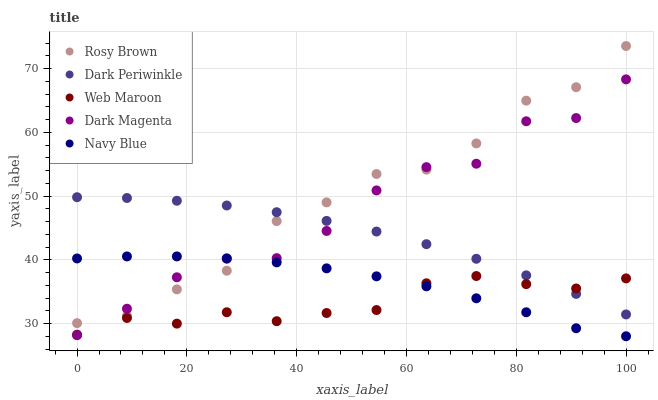Does Web Maroon have the minimum area under the curve?
Answer yes or no. Yes. Does Rosy Brown have the maximum area under the curve?
Answer yes or no. Yes. Does Rosy Brown have the minimum area under the curve?
Answer yes or no. No. Does Web Maroon have the maximum area under the curve?
Answer yes or no. No. Is Dark Periwinkle the smoothest?
Answer yes or no. Yes. Is Dark Magenta the roughest?
Answer yes or no. Yes. Is Rosy Brown the smoothest?
Answer yes or no. No. Is Rosy Brown the roughest?
Answer yes or no. No. Does Navy Blue have the lowest value?
Answer yes or no. Yes. Does Rosy Brown have the lowest value?
Answer yes or no. No. Does Rosy Brown have the highest value?
Answer yes or no. Yes. Does Web Maroon have the highest value?
Answer yes or no. No. Is Navy Blue less than Dark Periwinkle?
Answer yes or no. Yes. Is Rosy Brown greater than Web Maroon?
Answer yes or no. Yes. Does Rosy Brown intersect Dark Magenta?
Answer yes or no. Yes. Is Rosy Brown less than Dark Magenta?
Answer yes or no. No. Is Rosy Brown greater than Dark Magenta?
Answer yes or no. No. Does Navy Blue intersect Dark Periwinkle?
Answer yes or no. No. 